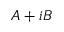Convert formula to latex. <formula><loc_0><loc_0><loc_500><loc_500>A + i B</formula> 